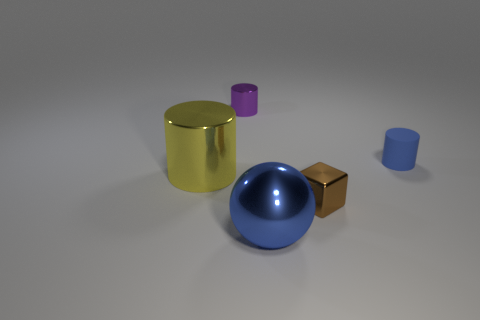There is a big metal sphere that is in front of the tiny cylinder that is to the right of the tiny metal object that is left of the big ball; what color is it?
Your response must be concise. Blue. Are the purple object and the big yellow cylinder made of the same material?
Provide a short and direct response. Yes. There is a small brown metal block; what number of small brown cubes are left of it?
Your response must be concise. 0. There is a purple metal thing that is the same shape as the yellow metal object; what is its size?
Provide a succinct answer. Small. What number of blue objects are small cylinders or shiny spheres?
Your answer should be compact. 2. How many metallic blocks are on the left side of the shiny cylinder that is behind the blue matte cylinder?
Your answer should be compact. 0. What number of other things are there of the same shape as the tiny brown metallic object?
Ensure brevity in your answer.  0. What is the material of the small cylinder that is the same color as the shiny sphere?
Provide a short and direct response. Rubber. What number of tiny matte cylinders have the same color as the ball?
Ensure brevity in your answer.  1. There is another small thing that is the same material as the small purple thing; what is its color?
Your response must be concise. Brown. 